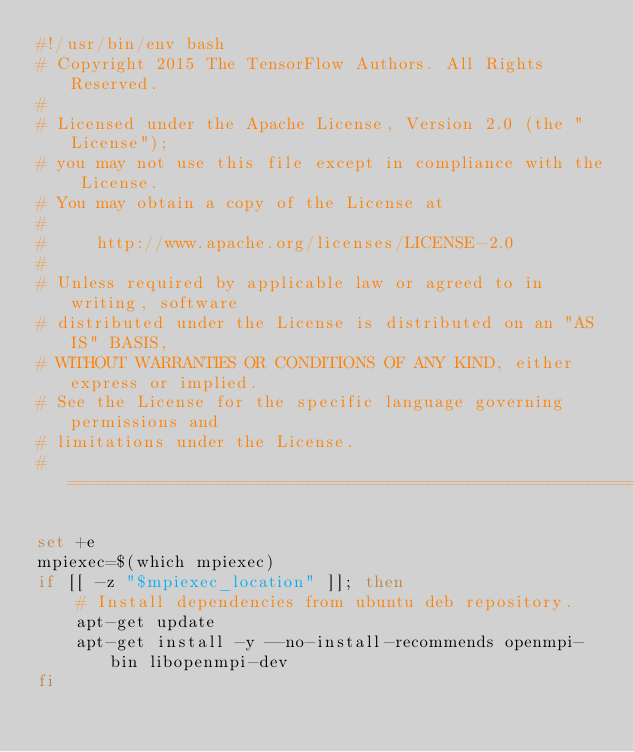Convert code to text. <code><loc_0><loc_0><loc_500><loc_500><_Bash_>#!/usr/bin/env bash
# Copyright 2015 The TensorFlow Authors. All Rights Reserved.
#
# Licensed under the Apache License, Version 2.0 (the "License");
# you may not use this file except in compliance with the License.
# You may obtain a copy of the License at
#
#     http://www.apache.org/licenses/LICENSE-2.0
#
# Unless required by applicable law or agreed to in writing, software
# distributed under the License is distributed on an "AS IS" BASIS,
# WITHOUT WARRANTIES OR CONDITIONS OF ANY KIND, either express or implied.
# See the License for the specific language governing permissions and
# limitations under the License.
# ==============================================================================

set +e
mpiexec=$(which mpiexec)
if [[ -z "$mpiexec_location" ]]; then
    # Install dependencies from ubuntu deb repository.
    apt-get update
    apt-get install -y --no-install-recommends openmpi-bin libopenmpi-dev
fi
</code> 